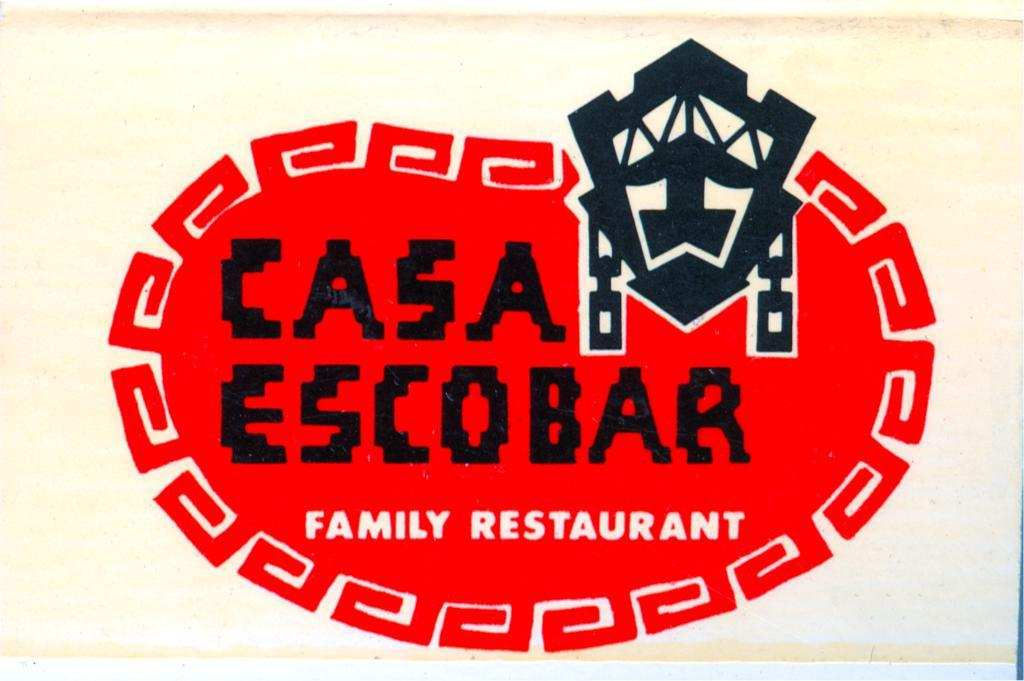<image>
Relay a brief, clear account of the picture shown. A sign in white with a red logo of the Casa Escobar Family Restaurant. 